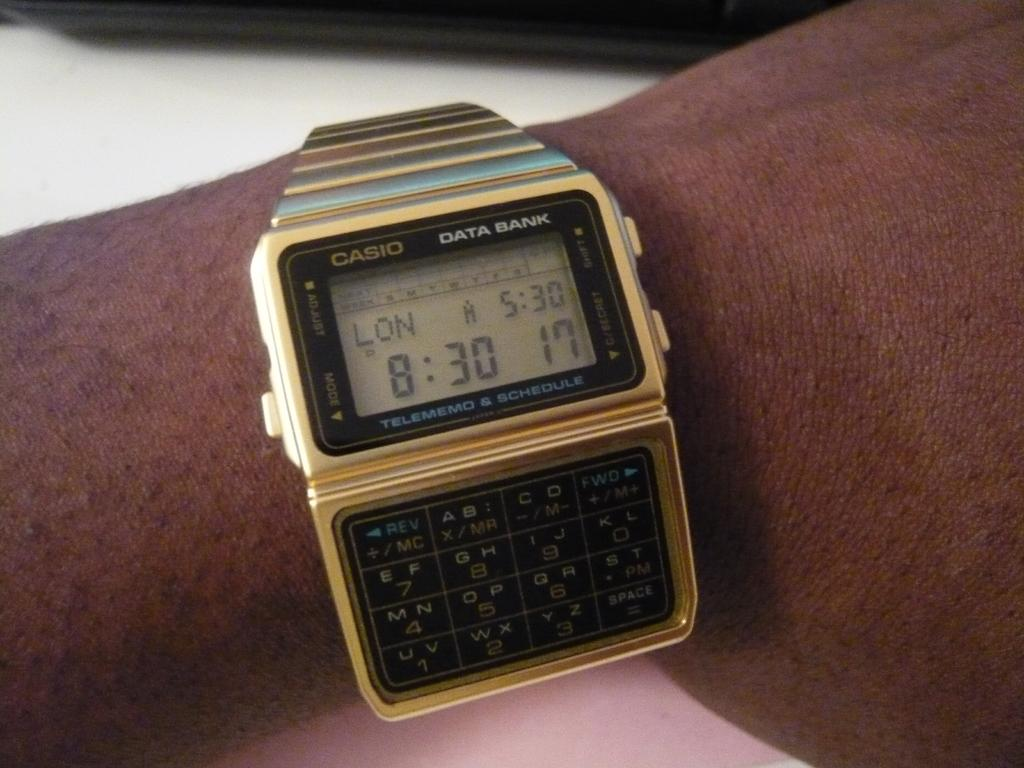<image>
Offer a succinct explanation of the picture presented. A Casio watch shows the time in London as well as the time in the current location. 